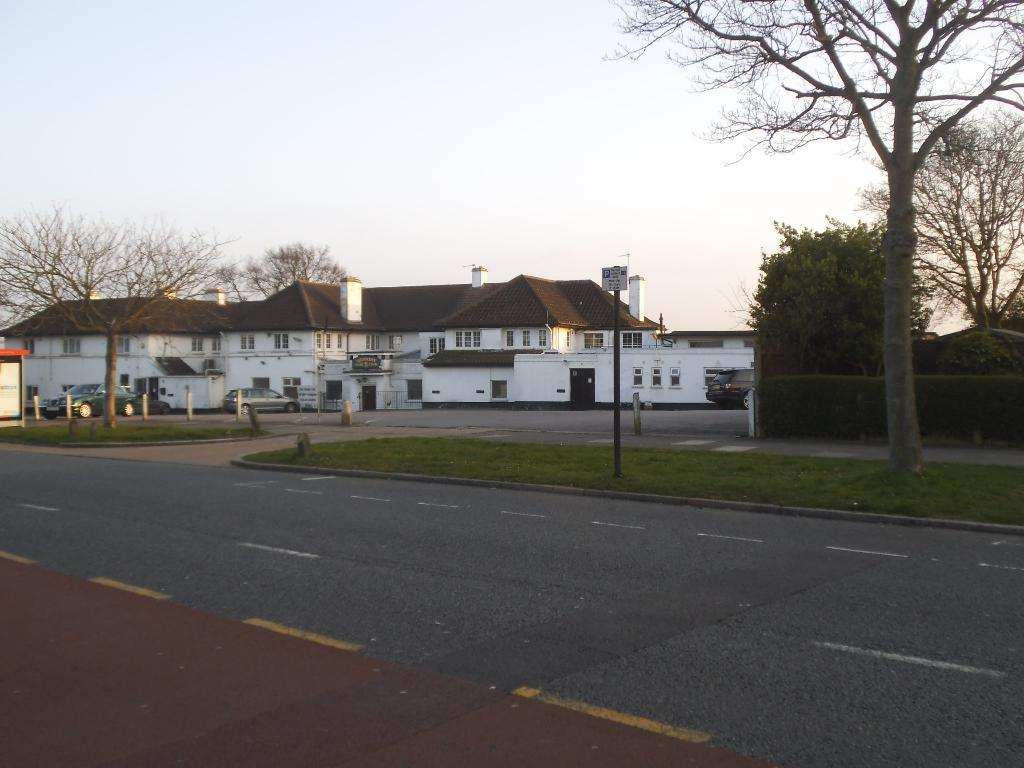What type of surface can be seen in the image? There is a road in the image. What object is present near the road? There is a pole in the image. What is the board in the image used for? The board in the image may be used for displaying information or artwork. What type of vegetation is present in the image? There is grass in the image. What type of vehicles can be seen in the image? There are cars in the image. What celestial bodies are depicted in the image? There are planets depicted in the image, possibly on the board. What type of residential structures are present in the image? There are houses in the image. What type of plants are present in the image? There are trees in the image. What can be seen in the background of the image? The sky is visible in the background of the image. Can you tell me how many snails are crawling on the road in the image? There are no snails present on the road in the image. Is there a skateboarder performing tricks on the pole in the image? There is no skateboarder or any indication of a skateboard in the image. 